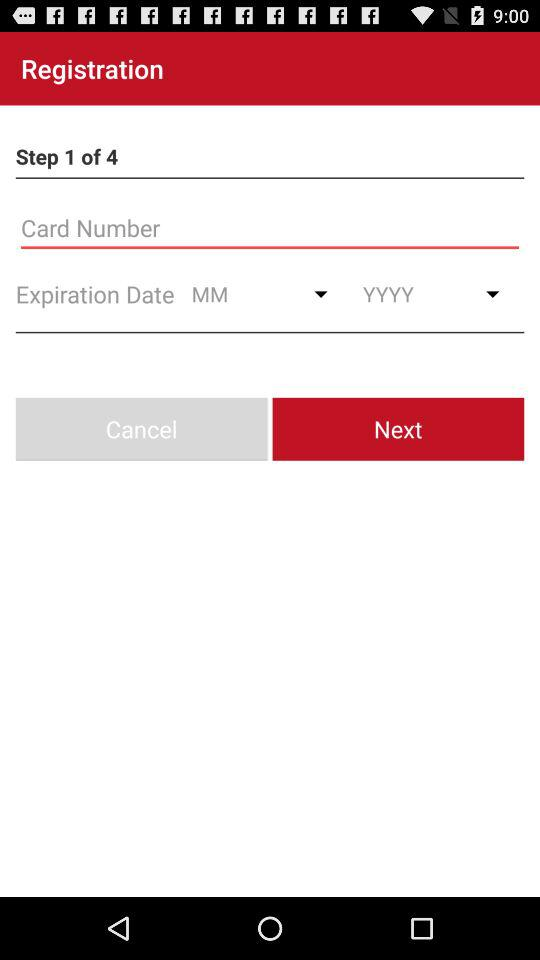How many steps are there in the registration process?
Answer the question using a single word or phrase. 4 